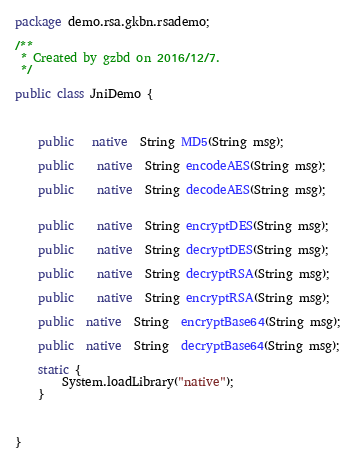<code> <loc_0><loc_0><loc_500><loc_500><_Java_>package demo.rsa.gkbn.rsademo;

/**
 * Created by gzbd on 2016/12/7.
 */

public class JniDemo {



    public   native  String MD5(String msg);

    public    native  String encodeAES(String msg);

    public    native  String decodeAES(String msg);


    public    native  String encryptDES(String msg);

    public    native  String decryptDES(String msg);

    public    native  String decryptRSA(String msg);

    public    native  String encryptRSA(String msg);

    public  native  String  encryptBase64(String msg);

    public  native  String  decryptBase64(String msg);

    static {
        System.loadLibrary("native");
    }



}
</code> 